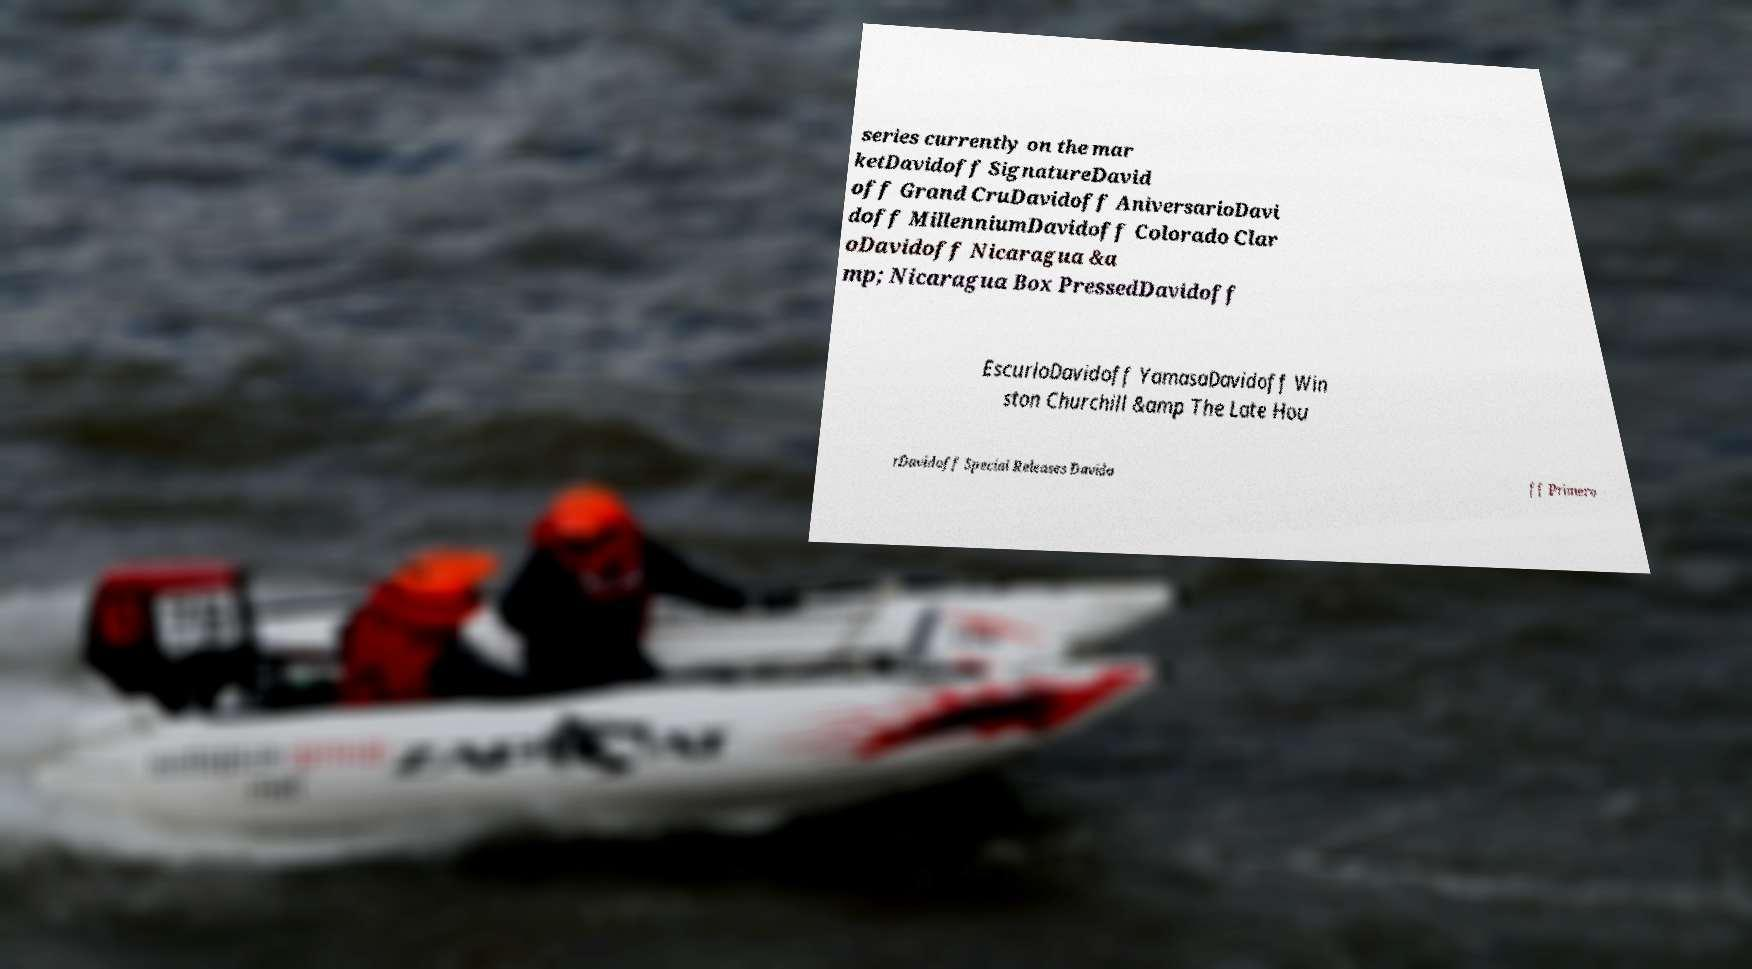Please read and relay the text visible in this image. What does it say? series currently on the mar ketDavidoff SignatureDavid off Grand CruDavidoff AniversarioDavi doff MillenniumDavidoff Colorado Clar oDavidoff Nicaragua &a mp; Nicaragua Box PressedDavidoff EscurioDavidoff YamasaDavidoff Win ston Churchill &amp The Late Hou rDavidoff Special Releases Davido ff Primero 